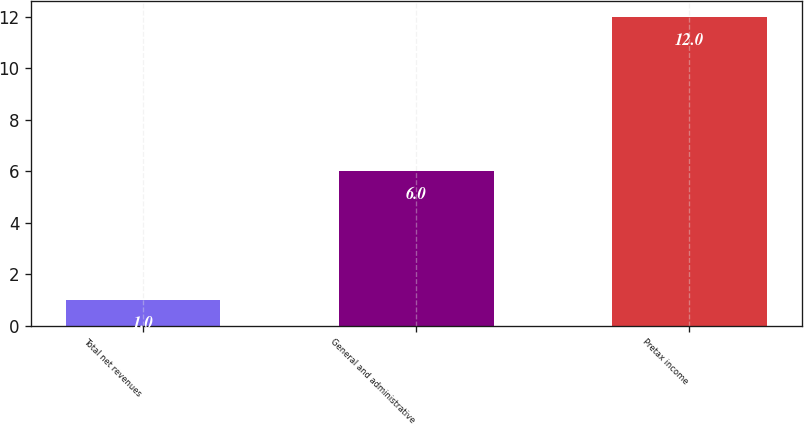<chart> <loc_0><loc_0><loc_500><loc_500><bar_chart><fcel>Total net revenues<fcel>General and administrative<fcel>Pretax income<nl><fcel>1<fcel>6<fcel>12<nl></chart> 